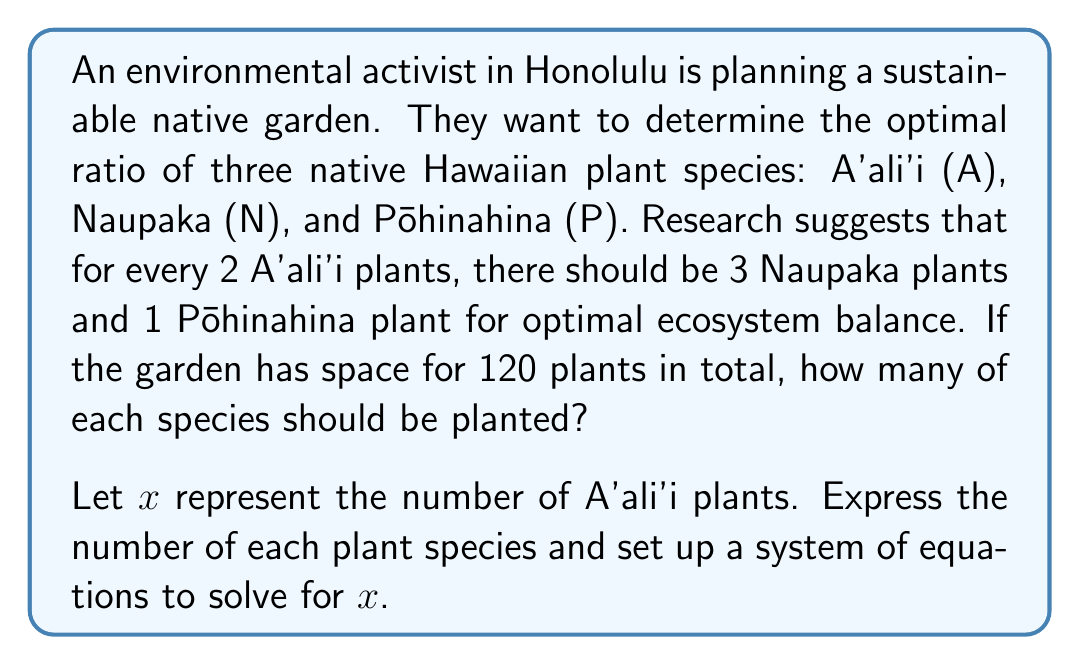Provide a solution to this math problem. Let's approach this step-by-step:

1) Let $x$ represent the number of A'ali'i plants.

2) Based on the given ratio, we can express the other plants in terms of $x$:
   Naupaka: $\frac{3}{2}x$
   Pōhinahina: $\frac{1}{2}x$

3) The total number of plants is 120, so we can set up the equation:

   $$x + \frac{3}{2}x + \frac{1}{2}x = 120$$

4) Simplify the left side of the equation:

   $$x + \frac{3}{2}x + \frac{1}{2}x = x + 1.5x + 0.5x = 3x = 120$$

5) Solve for $x$:

   $$x = 120 \div 3 = 40$$

6) Now that we know $x$, we can calculate the number of each plant:

   A'ali'i (A): $x = 40$
   Naupaka (N): $\frac{3}{2}x = \frac{3}{2}(40) = 60$
   Pōhinahina (P): $\frac{1}{2}x = \frac{1}{2}(40) = 20$

7) Verify: $40 + 60 + 20 = 120$, which matches the total number of plants.
Answer: The optimal number of plants for the sustainable garden is:
A'ali'i (A): 40 plants
Naupaka (N): 60 plants
Pōhinahina (P): 20 plants 